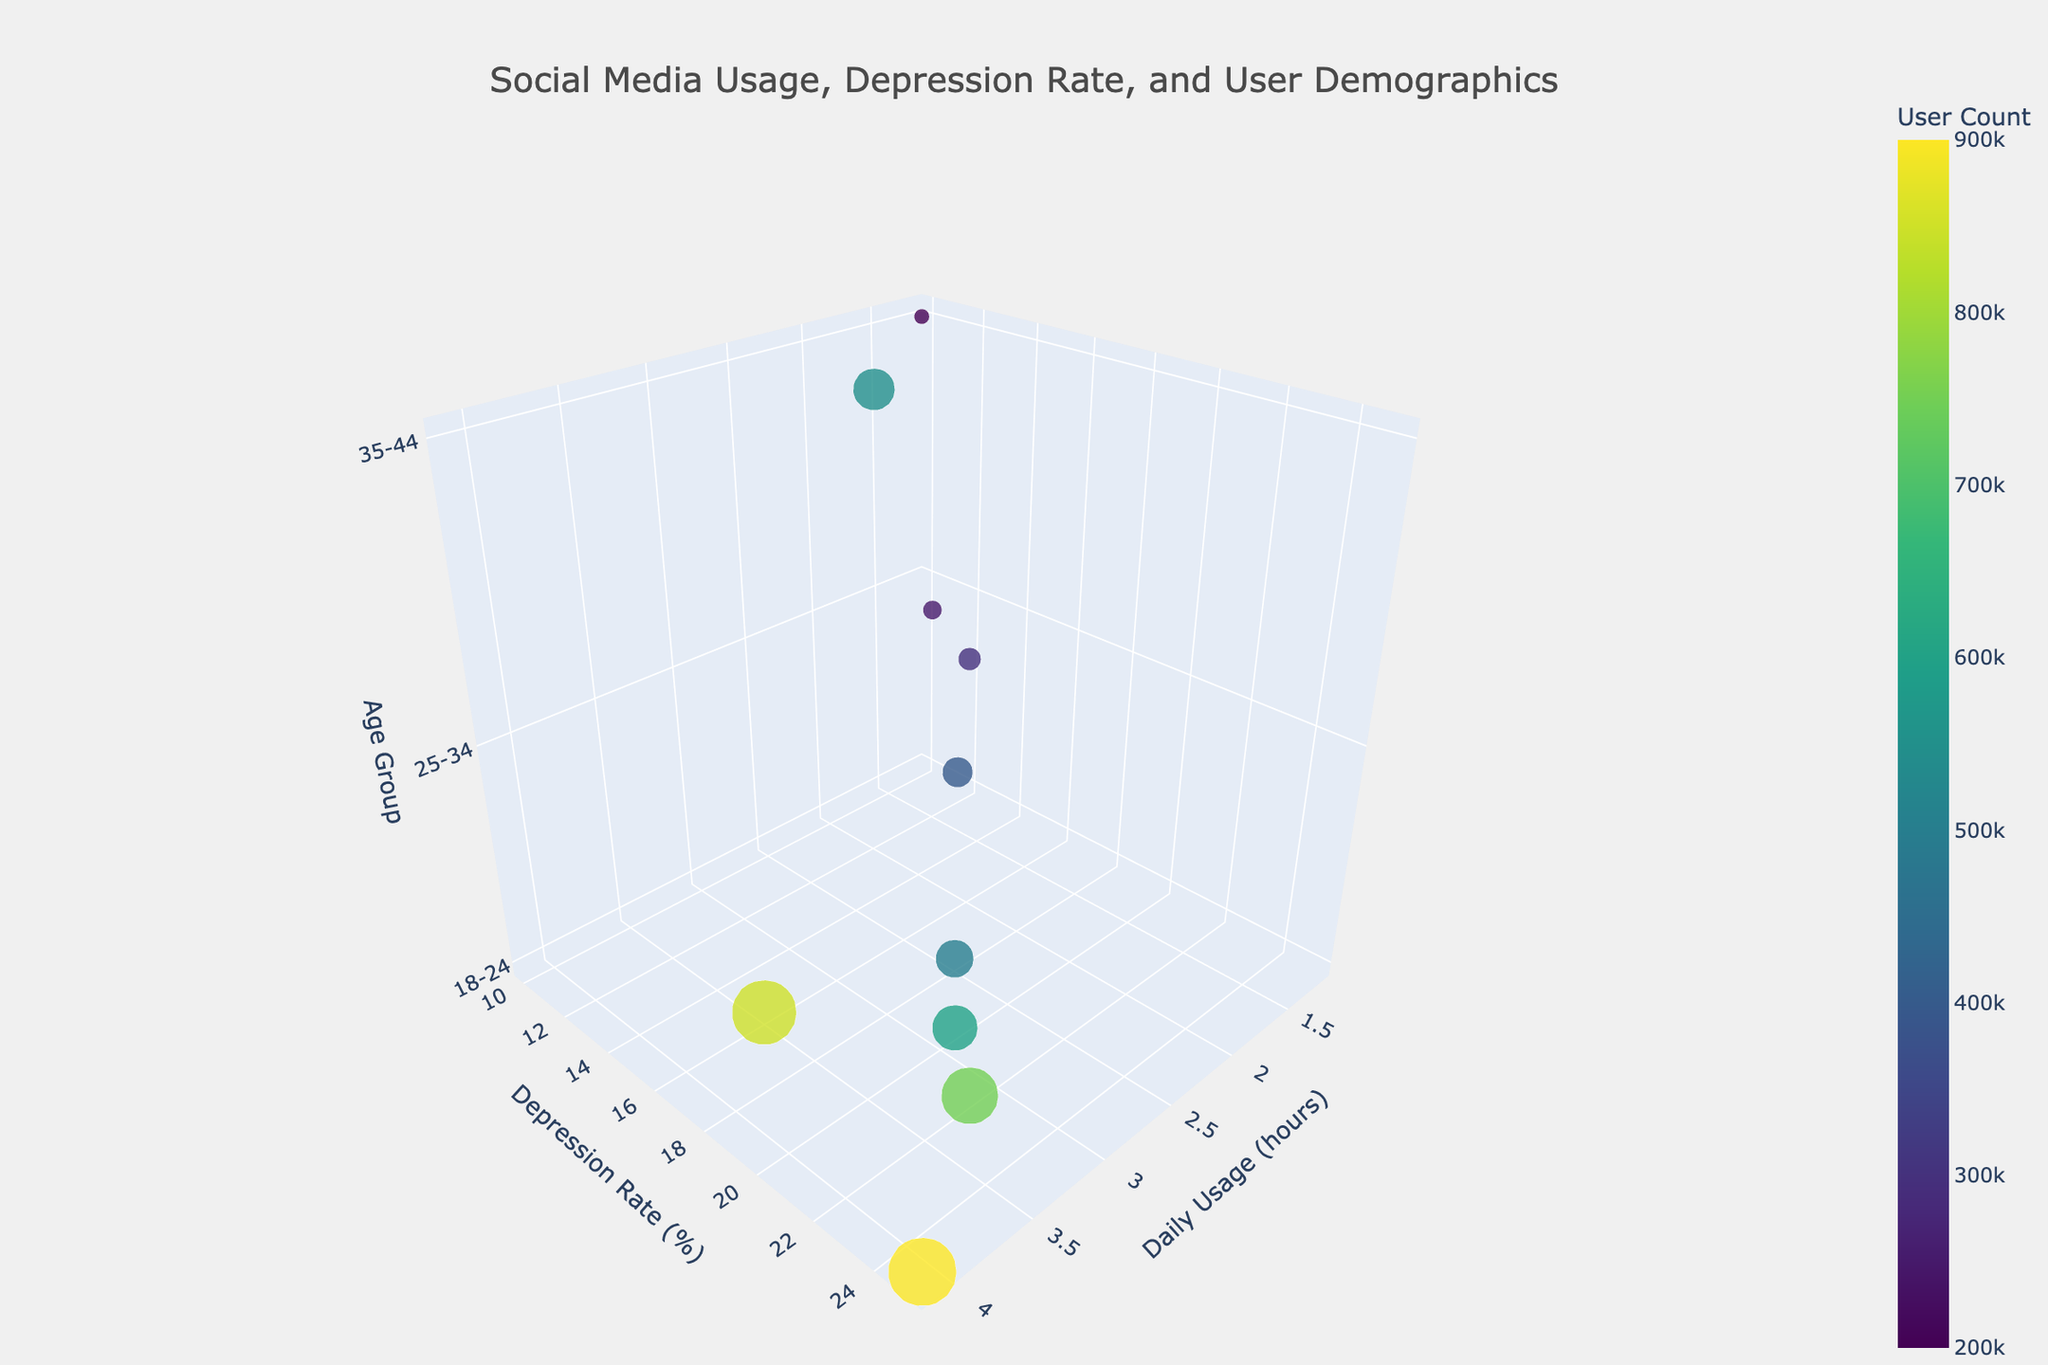What's the title of the 3D bubble chart? The title is shown at the top of the chart. It reads, "Social Media Usage, Depression Rate, and User Demographics."
Answer: Social Media Usage, Depression Rate, and User Demographics How many platforms are represented in the chart? Count the number of distinct bubbles in the chart since each bubble represents a different platform.
Answer: 10 Which platform has the highest daily usage hours? Look for the bubble that extends the furthest along the x-axis, which represents daily usage hours.
Answer: TikTok What is the depression rate for users aged 25-34 on Reddit? Find the bubble labeled "Reddit" and check its position on the y-axis, which represents depression rate.
Answer: 19% Compare the depression rate of Instagram and Twitter users. Which has a higher rate? Identify the bubbles labeled "Instagram" and "Twitter" and compare their positions along the y-axis.
Answer: Instagram Is there a platform used more by the 35-44 age group than LinkedIn? Check if there is any other bubble located on the z-axis value for 35-44 that has a larger representing bubble (larger user count).
Answer: No Which platform has the highest user count? Locate the largest bubble in the chart since the bubble size represents user count.
Answer: TikTok What's the average depression rate for platforms used by the 18-24 age group? Identify all bubbles for the 18-24 age group. The depression rates are 18 (Facebook), 22 (Instagram), 25 (TikTok), 20 (Snapchat), 16 (YouTube). Sum these rates and divide by the number of platforms (5). The calculation is (18+22+25+20+16)/5 = 20.2.
Answer: 20.2 Which platform has the lowest depression rate among users aged 35-44? Identify the bubbles within the z-axis value for 35-44 and compare their positions along the y-axis, which represents depression rates.
Answer: LinkedIn How do the daily usage hours of YouTube and Pinterest compare? Check the x-axis values for the bubbles labeled "YouTube" and "Pinterest."
Answer: YouTube has more daily usage hours 